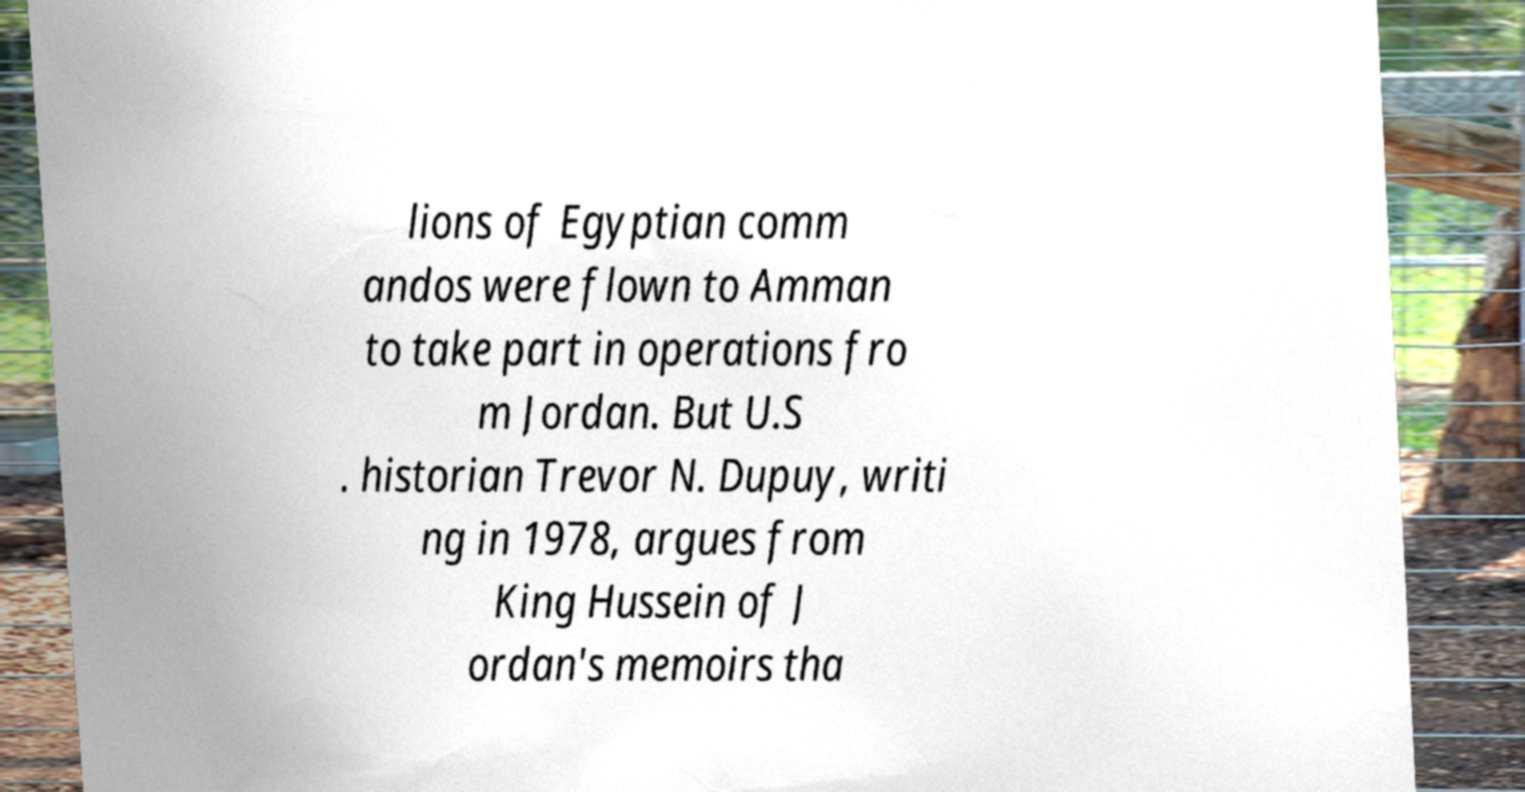Please read and relay the text visible in this image. What does it say? lions of Egyptian comm andos were flown to Amman to take part in operations fro m Jordan. But U.S . historian Trevor N. Dupuy, writi ng in 1978, argues from King Hussein of J ordan's memoirs tha 